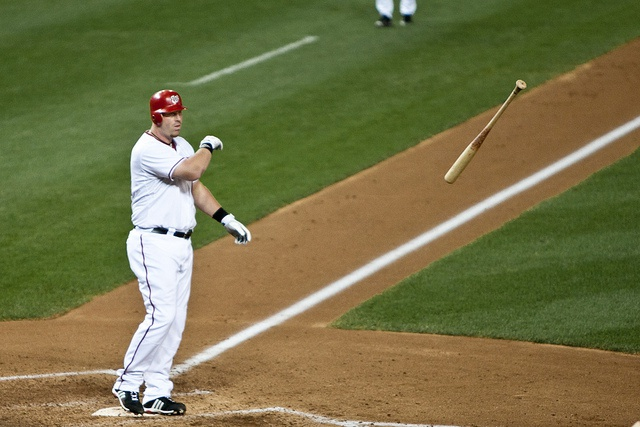Describe the objects in this image and their specific colors. I can see people in darkgreen, lavender, black, darkgray, and gray tones, baseball bat in darkgreen, olive, and tan tones, and people in darkgreen, lavender, black, gray, and darkgray tones in this image. 